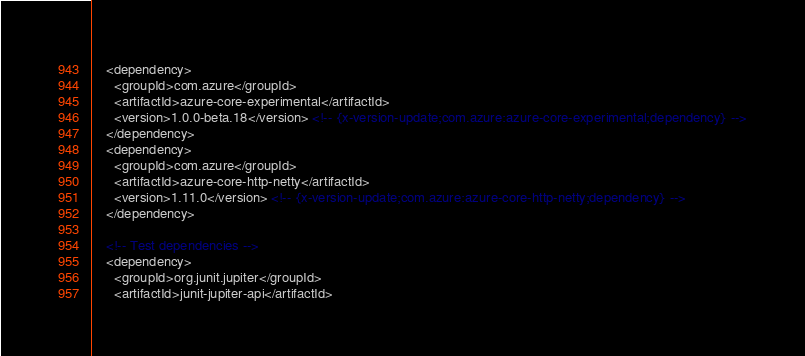Convert code to text. <code><loc_0><loc_0><loc_500><loc_500><_XML_>    <dependency>
      <groupId>com.azure</groupId>
      <artifactId>azure-core-experimental</artifactId>
      <version>1.0.0-beta.18</version> <!-- {x-version-update;com.azure:azure-core-experimental;dependency} -->
    </dependency>
    <dependency>
      <groupId>com.azure</groupId>
      <artifactId>azure-core-http-netty</artifactId>
      <version>1.11.0</version> <!-- {x-version-update;com.azure:azure-core-http-netty;dependency} -->
    </dependency>

    <!-- Test dependencies -->
    <dependency>
      <groupId>org.junit.jupiter</groupId>
      <artifactId>junit-jupiter-api</artifactId></code> 